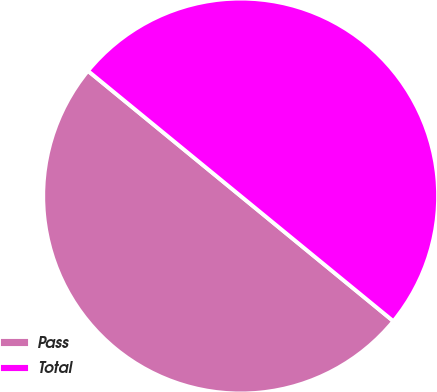Convert chart. <chart><loc_0><loc_0><loc_500><loc_500><pie_chart><fcel>Pass<fcel>Total<nl><fcel>50.0%<fcel>50.0%<nl></chart> 